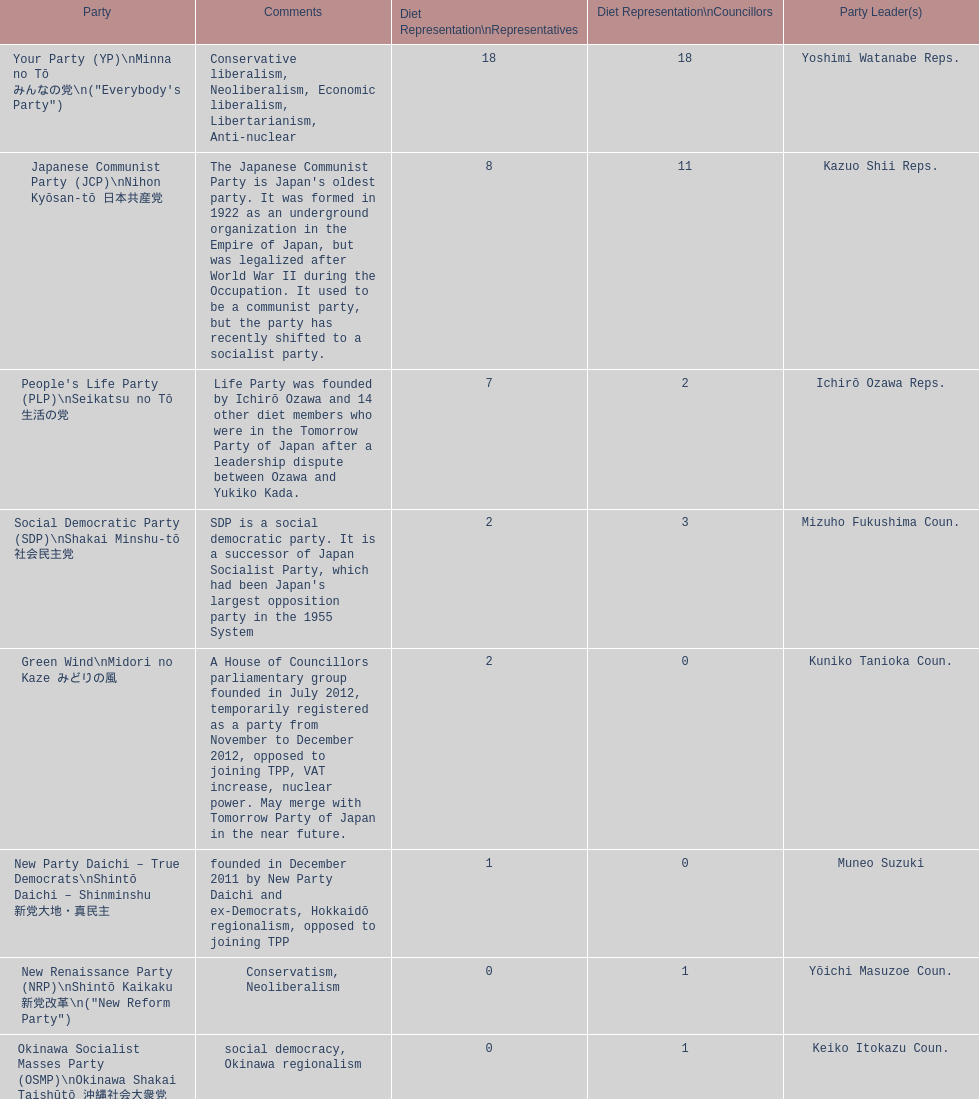How many representatives come from the green wind party? 2. 